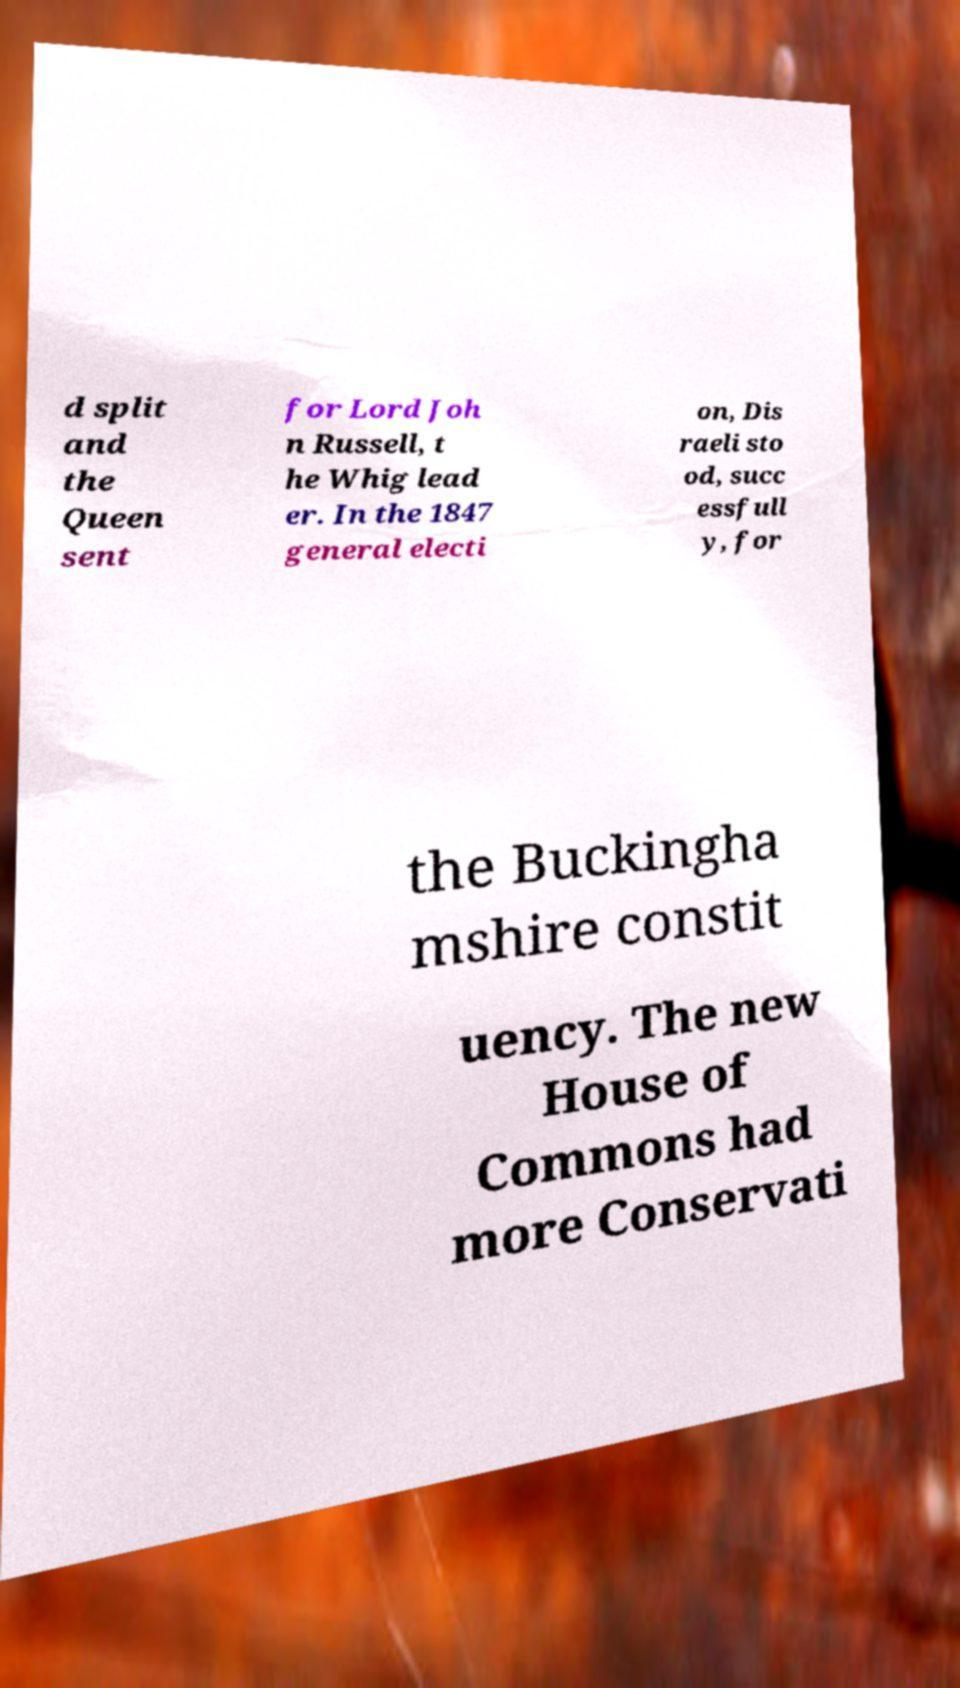There's text embedded in this image that I need extracted. Can you transcribe it verbatim? d split and the Queen sent for Lord Joh n Russell, t he Whig lead er. In the 1847 general electi on, Dis raeli sto od, succ essfull y, for the Buckingha mshire constit uency. The new House of Commons had more Conservati 